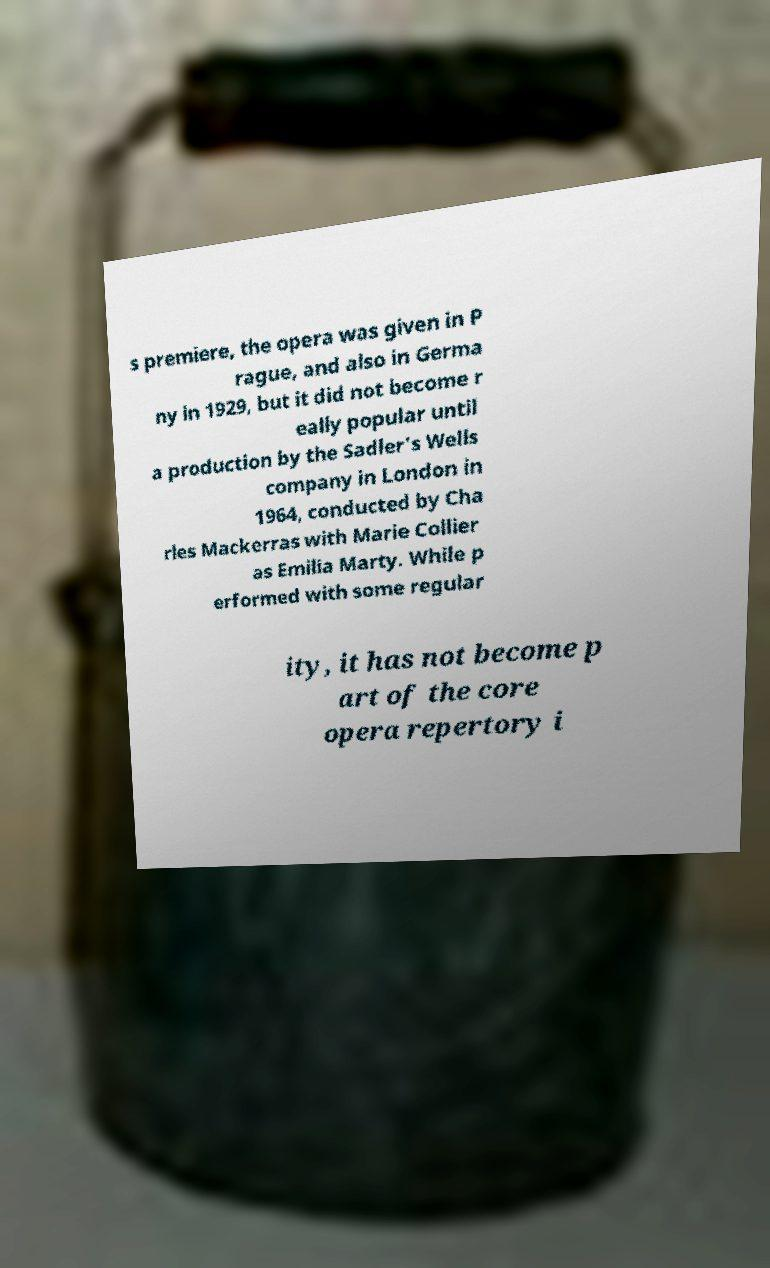What messages or text are displayed in this image? I need them in a readable, typed format. s premiere, the opera was given in P rague, and also in Germa ny in 1929, but it did not become r eally popular until a production by the Sadler's Wells company in London in 1964, conducted by Cha rles Mackerras with Marie Collier as Emilia Marty. While p erformed with some regular ity, it has not become p art of the core opera repertory i 